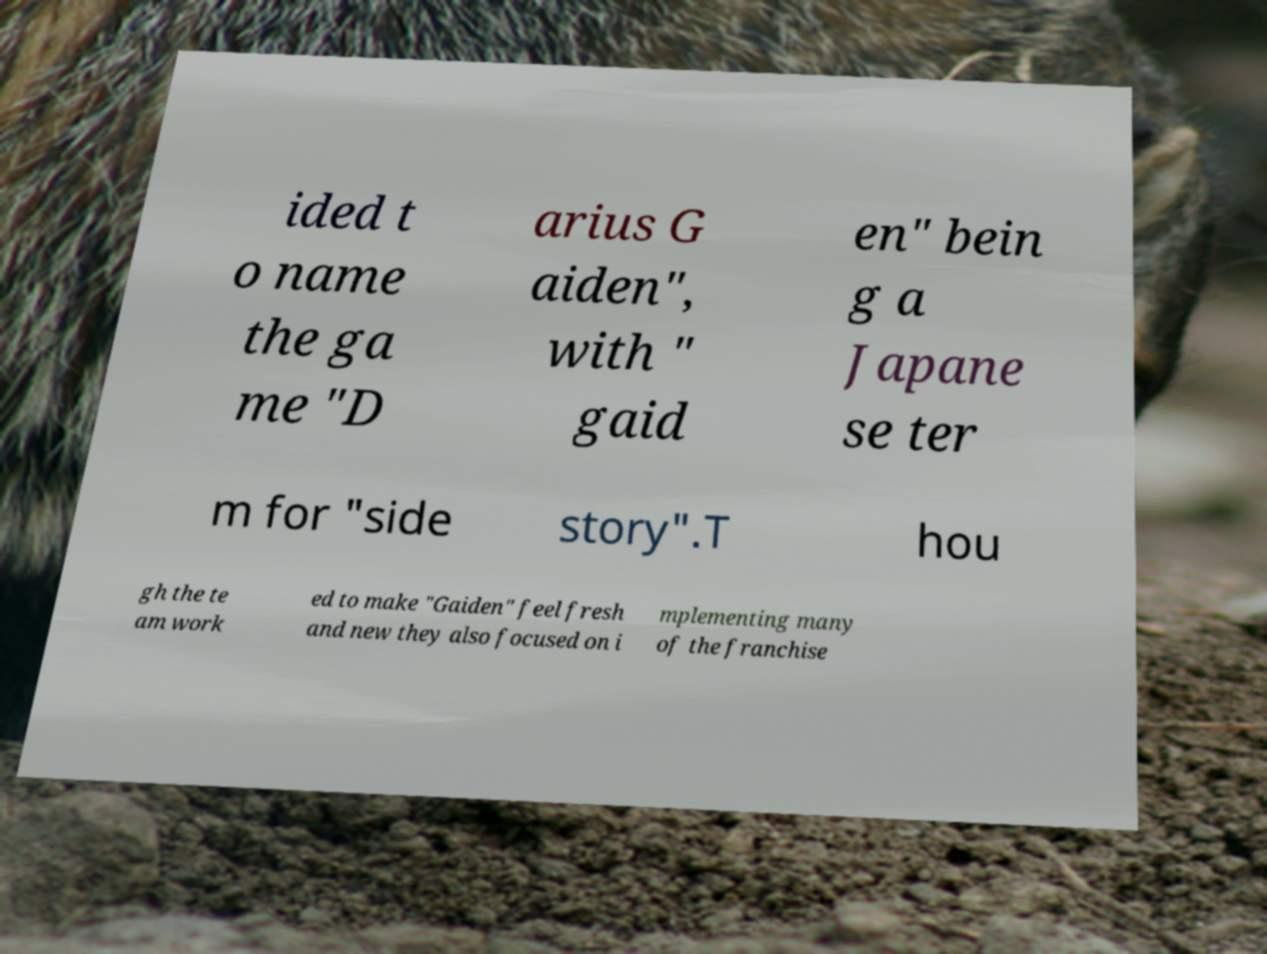There's text embedded in this image that I need extracted. Can you transcribe it verbatim? ided t o name the ga me "D arius G aiden", with " gaid en" bein g a Japane se ter m for "side story".T hou gh the te am work ed to make "Gaiden" feel fresh and new they also focused on i mplementing many of the franchise 